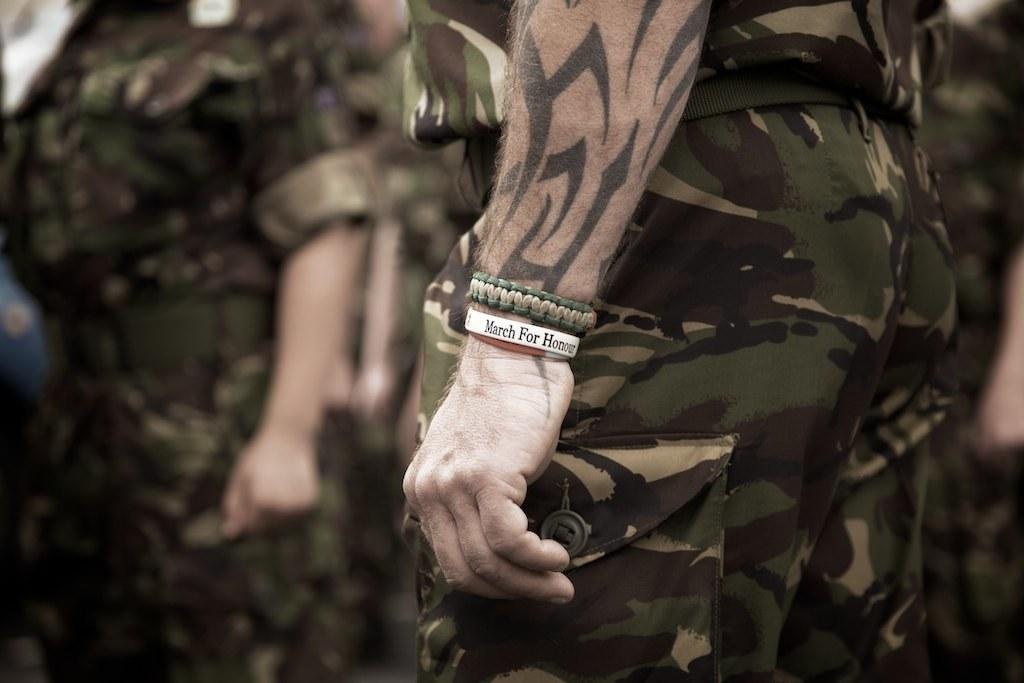What can be seen in the image? There is a group of persons in the image. What are the persons wearing? The persons are wearing military uniforms. Can you describe any specific details about one of the persons? One person is wearing bands on his hand. What is the son of the person wearing bands on his hand doing in the image? There is no mention of a son or any other person's actions in the image; it only shows a group of persons wearing military uniforms, with one person having bands on his hand. 